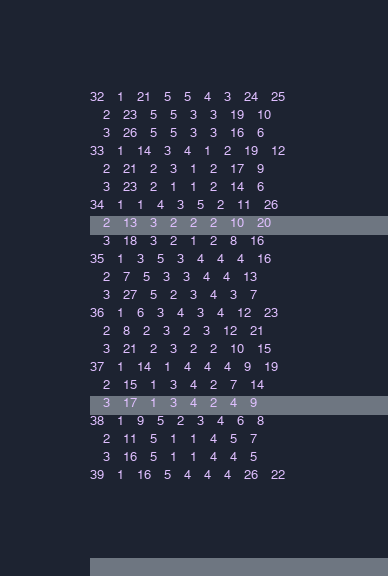<code> <loc_0><loc_0><loc_500><loc_500><_ObjectiveC_>32	1	21	5	5	4	3	24	25	
	2	23	5	5	3	3	19	10	
	3	26	5	5	3	3	16	6	
33	1	14	3	4	1	2	19	12	
	2	21	2	3	1	2	17	9	
	3	23	2	1	1	2	14	6	
34	1	1	4	3	5	2	11	26	
	2	13	3	2	2	2	10	20	
	3	18	3	2	1	2	8	16	
35	1	3	5	3	4	4	4	16	
	2	7	5	3	3	4	4	13	
	3	27	5	2	3	4	3	7	
36	1	6	3	4	3	4	12	23	
	2	8	2	3	2	3	12	21	
	3	21	2	3	2	2	10	15	
37	1	14	1	4	4	4	9	19	
	2	15	1	3	4	2	7	14	
	3	17	1	3	4	2	4	9	
38	1	9	5	2	3	4	6	8	
	2	11	5	1	1	4	5	7	
	3	16	5	1	1	4	4	5	
39	1	16	5	4	4	4	26	22	</code> 